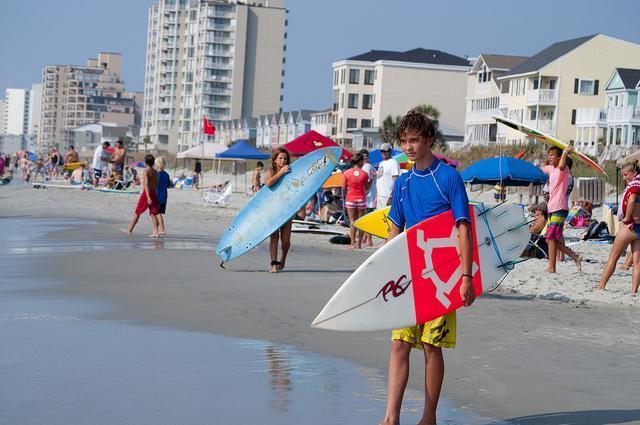How many people are there?
Give a very brief answer. 3. How many surfboards are there?
Give a very brief answer. 2. 